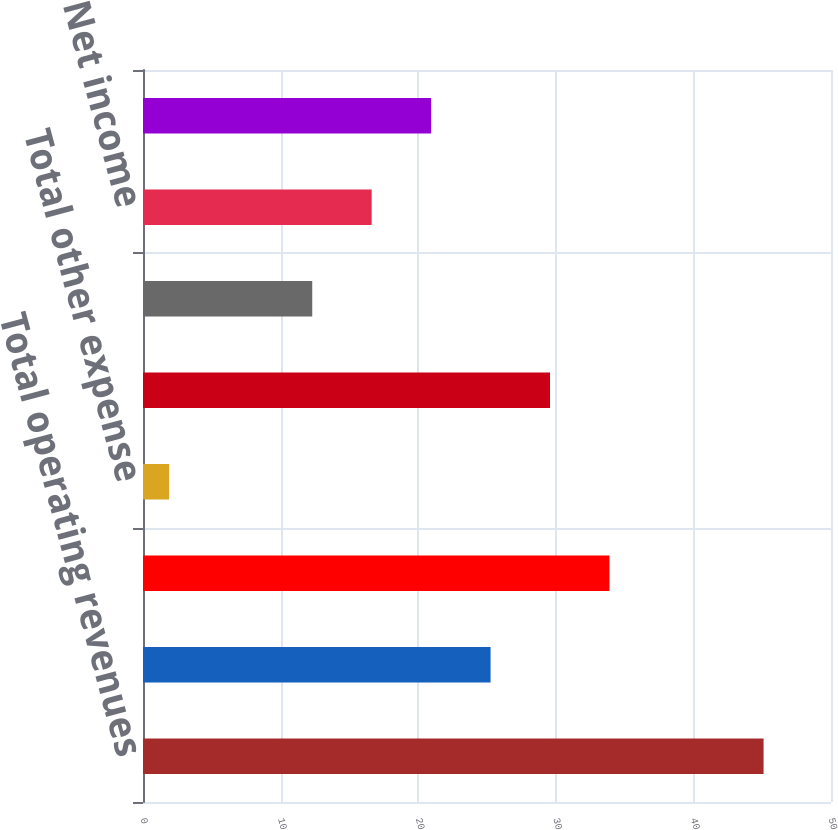<chart> <loc_0><loc_0><loc_500><loc_500><bar_chart><fcel>Total operating revenues<fcel>Total operating expenses<fcel>Operating income<fcel>Total other expense<fcel>Income before income taxes<fcel>Income tax provision<fcel>Net income<fcel>Net income allocated to common<nl><fcel>45.1<fcel>25.26<fcel>33.9<fcel>1.9<fcel>29.58<fcel>12.3<fcel>16.62<fcel>20.94<nl></chart> 